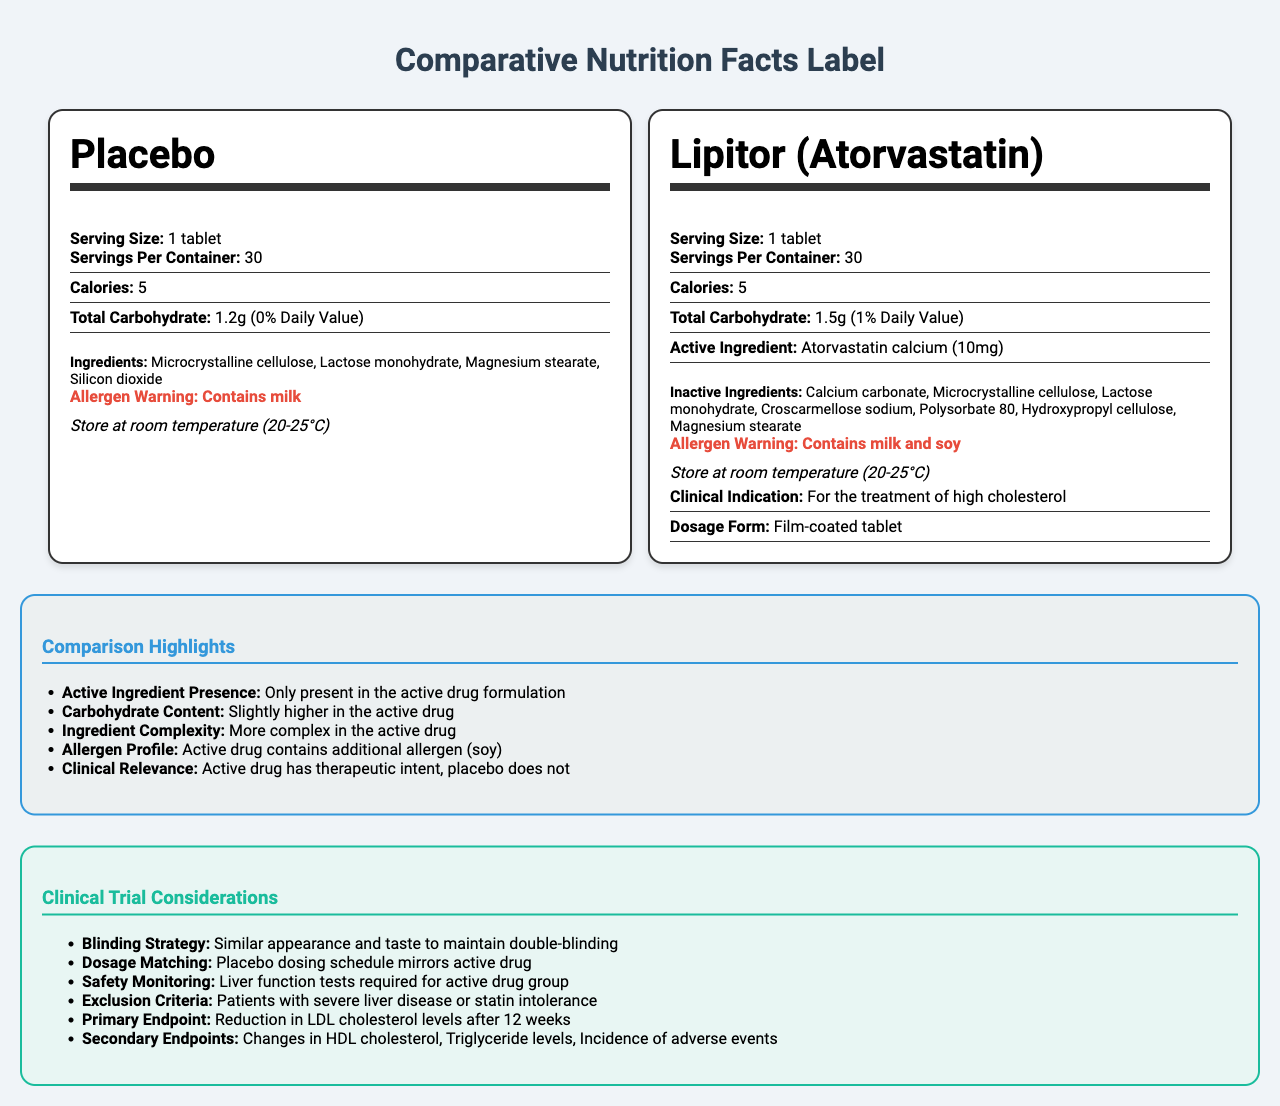what is the serving size for the placebo? The document shows the serving size for the placebo as "1 tablet" under the "Placebo" label section.
Answer: 1 tablet how many calories per serving are in both the placebo and the active drug? The label sections for both the placebo and active drug state that each contains "5 calories" per serving.
Answer: 5 calories what is the total carbohydrate amount in the active drug? Under the "Lipitor (Atorvastatin)" section, the total carbohydrate is listed as "1.5g".
Answer: 1.5g which additional allergen is present in the active drug but not in the placebo? The allergen warning for the active drug states "Contains milk and soy," while the placebo only contains milk.
Answer: Soy how many servings per container are provided for both the placebo and active drug? Both the placebo and active drug sections state "Servings Per Container: 30."
Answer: 30 servings per container which of the following is an active ingredient in the active drug? I. Microcrystalline cellulose II. Atorvastatin calcium III. Hydroxypropyl cellulose Atorvastatin calcium is listed as the active ingredient in the active drug, whereas the others are inactive ingredients.
Answer: II what is the primary endpoint of the clinical trial? Under "Clinical Trial Considerations," it states the primary endpoint as "Reduction in LDL cholesterol levels after 12 weeks."
Answer: Reduction in LDL cholesterol levels after 12 weeks does the placebo contain any active ingredients? The placebo section lists no active ingredients, contrasting with the active drug which contains Atorvastatin calcium.
Answer: No summarize the key differences between the placebo and the active drug mentioned in the document. The document highlights that the active drug contains Atorvastatin calcium, used to treat high cholesterol, and has additional ingredients and allergens compared to the placebo. The active drug also has specific storage instructions and clinical indications not present for the placebo.
Answer: The active drug contains an active ingredient, Atorvastatin calcium, while the placebo does not. The carbohydrate content is slightly higher in the active drug. The active drug has a more complex ingredient list and contains an additional allergen (soy). The active drug has clinical relevance for treating high cholesterol, whereas the placebo does not. what is the clinical indication of the active drug? The active drug label clearly states "Clinical Indication: For the treatment of high cholesterol."
Answer: For the treatment of high cholesterol what is the exclusion criteria mentioned for the clinical trial? The clinical trial considerations mention "Patients with severe liver disease or statin intolerance" as exclusion criteria.
Answer: Patients with severe liver disease or statin intolerance can you determine the complete manufacturing process of the placebo from this document? The document provides nutritional and ingredient information but does not detail the manufacturing process of the placebo.
Answer: Not enough information 